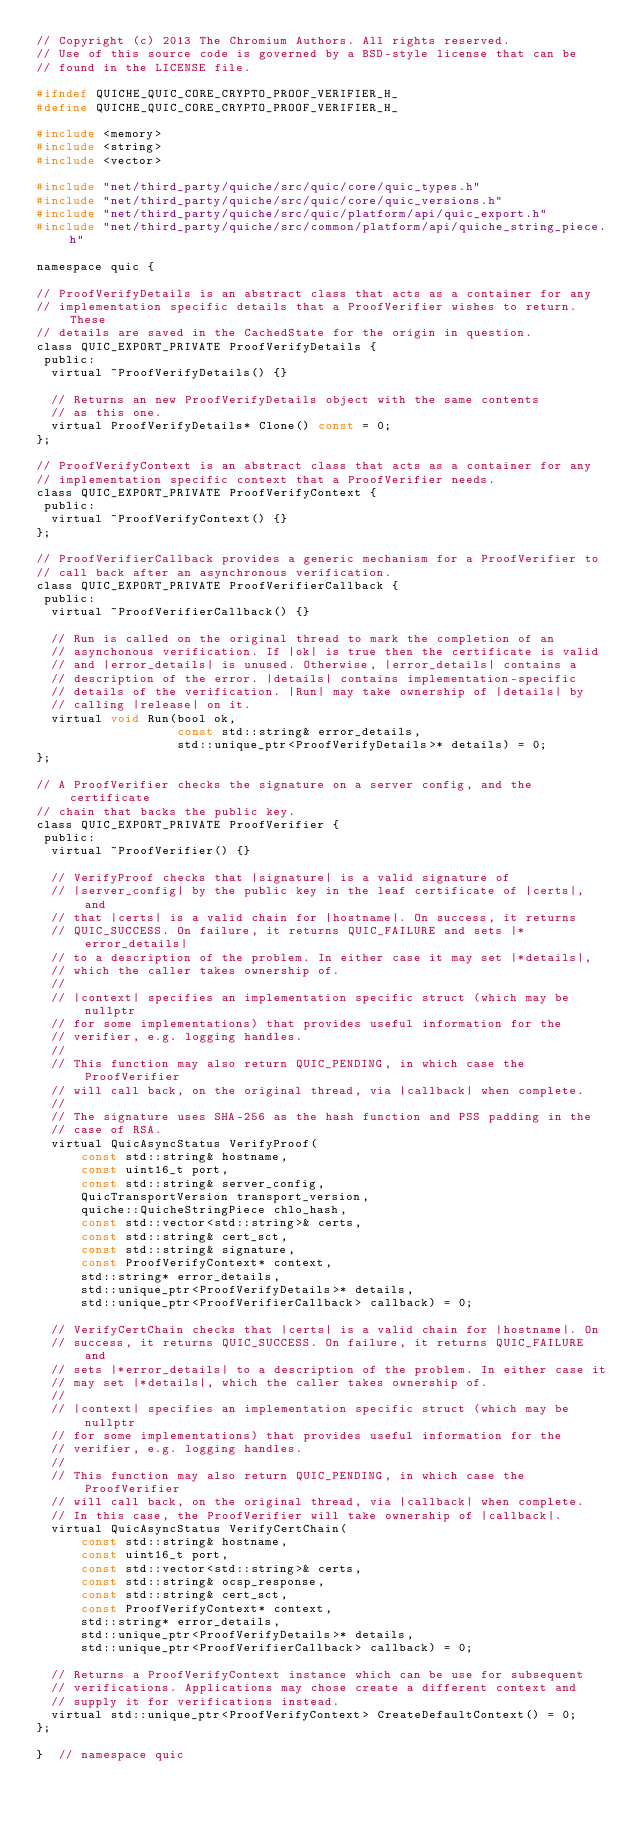Convert code to text. <code><loc_0><loc_0><loc_500><loc_500><_C_>// Copyright (c) 2013 The Chromium Authors. All rights reserved.
// Use of this source code is governed by a BSD-style license that can be
// found in the LICENSE file.

#ifndef QUICHE_QUIC_CORE_CRYPTO_PROOF_VERIFIER_H_
#define QUICHE_QUIC_CORE_CRYPTO_PROOF_VERIFIER_H_

#include <memory>
#include <string>
#include <vector>

#include "net/third_party/quiche/src/quic/core/quic_types.h"
#include "net/third_party/quiche/src/quic/core/quic_versions.h"
#include "net/third_party/quiche/src/quic/platform/api/quic_export.h"
#include "net/third_party/quiche/src/common/platform/api/quiche_string_piece.h"

namespace quic {

// ProofVerifyDetails is an abstract class that acts as a container for any
// implementation specific details that a ProofVerifier wishes to return. These
// details are saved in the CachedState for the origin in question.
class QUIC_EXPORT_PRIVATE ProofVerifyDetails {
 public:
  virtual ~ProofVerifyDetails() {}

  // Returns an new ProofVerifyDetails object with the same contents
  // as this one.
  virtual ProofVerifyDetails* Clone() const = 0;
};

// ProofVerifyContext is an abstract class that acts as a container for any
// implementation specific context that a ProofVerifier needs.
class QUIC_EXPORT_PRIVATE ProofVerifyContext {
 public:
  virtual ~ProofVerifyContext() {}
};

// ProofVerifierCallback provides a generic mechanism for a ProofVerifier to
// call back after an asynchronous verification.
class QUIC_EXPORT_PRIVATE ProofVerifierCallback {
 public:
  virtual ~ProofVerifierCallback() {}

  // Run is called on the original thread to mark the completion of an
  // asynchonous verification. If |ok| is true then the certificate is valid
  // and |error_details| is unused. Otherwise, |error_details| contains a
  // description of the error. |details| contains implementation-specific
  // details of the verification. |Run| may take ownership of |details| by
  // calling |release| on it.
  virtual void Run(bool ok,
                   const std::string& error_details,
                   std::unique_ptr<ProofVerifyDetails>* details) = 0;
};

// A ProofVerifier checks the signature on a server config, and the certificate
// chain that backs the public key.
class QUIC_EXPORT_PRIVATE ProofVerifier {
 public:
  virtual ~ProofVerifier() {}

  // VerifyProof checks that |signature| is a valid signature of
  // |server_config| by the public key in the leaf certificate of |certs|, and
  // that |certs| is a valid chain for |hostname|. On success, it returns
  // QUIC_SUCCESS. On failure, it returns QUIC_FAILURE and sets |*error_details|
  // to a description of the problem. In either case it may set |*details|,
  // which the caller takes ownership of.
  //
  // |context| specifies an implementation specific struct (which may be nullptr
  // for some implementations) that provides useful information for the
  // verifier, e.g. logging handles.
  //
  // This function may also return QUIC_PENDING, in which case the ProofVerifier
  // will call back, on the original thread, via |callback| when complete.
  //
  // The signature uses SHA-256 as the hash function and PSS padding in the
  // case of RSA.
  virtual QuicAsyncStatus VerifyProof(
      const std::string& hostname,
      const uint16_t port,
      const std::string& server_config,
      QuicTransportVersion transport_version,
      quiche::QuicheStringPiece chlo_hash,
      const std::vector<std::string>& certs,
      const std::string& cert_sct,
      const std::string& signature,
      const ProofVerifyContext* context,
      std::string* error_details,
      std::unique_ptr<ProofVerifyDetails>* details,
      std::unique_ptr<ProofVerifierCallback> callback) = 0;

  // VerifyCertChain checks that |certs| is a valid chain for |hostname|. On
  // success, it returns QUIC_SUCCESS. On failure, it returns QUIC_FAILURE and
  // sets |*error_details| to a description of the problem. In either case it
  // may set |*details|, which the caller takes ownership of.
  //
  // |context| specifies an implementation specific struct (which may be nullptr
  // for some implementations) that provides useful information for the
  // verifier, e.g. logging handles.
  //
  // This function may also return QUIC_PENDING, in which case the ProofVerifier
  // will call back, on the original thread, via |callback| when complete.
  // In this case, the ProofVerifier will take ownership of |callback|.
  virtual QuicAsyncStatus VerifyCertChain(
      const std::string& hostname,
      const uint16_t port,
      const std::vector<std::string>& certs,
      const std::string& ocsp_response,
      const std::string& cert_sct,
      const ProofVerifyContext* context,
      std::string* error_details,
      std::unique_ptr<ProofVerifyDetails>* details,
      std::unique_ptr<ProofVerifierCallback> callback) = 0;

  // Returns a ProofVerifyContext instance which can be use for subsequent
  // verifications. Applications may chose create a different context and
  // supply it for verifications instead.
  virtual std::unique_ptr<ProofVerifyContext> CreateDefaultContext() = 0;
};

}  // namespace quic
</code> 